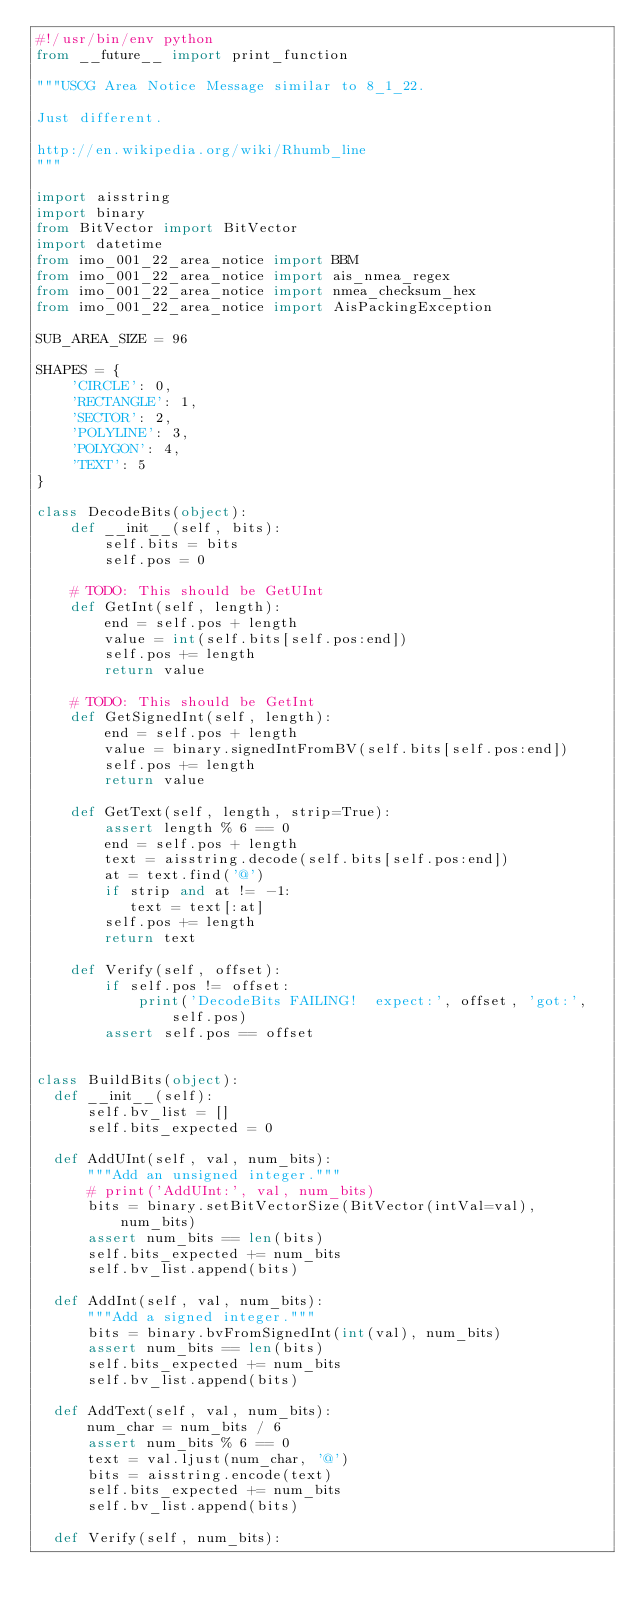Convert code to text. <code><loc_0><loc_0><loc_500><loc_500><_Python_>#!/usr/bin/env python
from __future__ import print_function

"""USCG Area Notice Message similar to 8_1_22.

Just different.

http://en.wikipedia.org/wiki/Rhumb_line
"""

import aisstring
import binary
from BitVector import BitVector
import datetime
from imo_001_22_area_notice import BBM
from imo_001_22_area_notice import ais_nmea_regex
from imo_001_22_area_notice import nmea_checksum_hex
from imo_001_22_area_notice import AisPackingException

SUB_AREA_SIZE = 96

SHAPES = {
    'CIRCLE': 0,
    'RECTANGLE': 1,
    'SECTOR': 2,
    'POLYLINE': 3,
    'POLYGON': 4,
    'TEXT': 5
}

class DecodeBits(object):
    def __init__(self, bits):
        self.bits = bits
        self.pos = 0

    # TODO: This should be GetUInt
    def GetInt(self, length):
        end = self.pos + length
        value = int(self.bits[self.pos:end])
        self.pos += length
        return value

    # TODO: This should be GetInt
    def GetSignedInt(self, length):
        end = self.pos + length
        value = binary.signedIntFromBV(self.bits[self.pos:end])
        self.pos += length
        return value

    def GetText(self, length, strip=True):
        assert length % 6 == 0
        end = self.pos + length
        text = aisstring.decode(self.bits[self.pos:end])
        at = text.find('@')
        if strip and at != -1:
           text = text[:at]
        self.pos += length
        return text

    def Verify(self, offset):
        if self.pos != offset:
            print('DecodeBits FAILING!  expect:', offset, 'got:', self.pos)
        assert self.pos == offset


class BuildBits(object):
  def __init__(self):
      self.bv_list = []
      self.bits_expected = 0

  def AddUInt(self, val, num_bits):
      """Add an unsigned integer."""
      # print('AddUInt:', val, num_bits)
      bits = binary.setBitVectorSize(BitVector(intVal=val), num_bits)
      assert num_bits == len(bits)
      self.bits_expected += num_bits
      self.bv_list.append(bits)

  def AddInt(self, val, num_bits):
      """Add a signed integer."""
      bits = binary.bvFromSignedInt(int(val), num_bits)
      assert num_bits == len(bits)
      self.bits_expected += num_bits
      self.bv_list.append(bits)

  def AddText(self, val, num_bits):
      num_char = num_bits / 6
      assert num_bits % 6 == 0
      text = val.ljust(num_char, '@')
      bits = aisstring.encode(text)
      self.bits_expected += num_bits
      self.bv_list.append(bits)

  def Verify(self, num_bits):</code> 